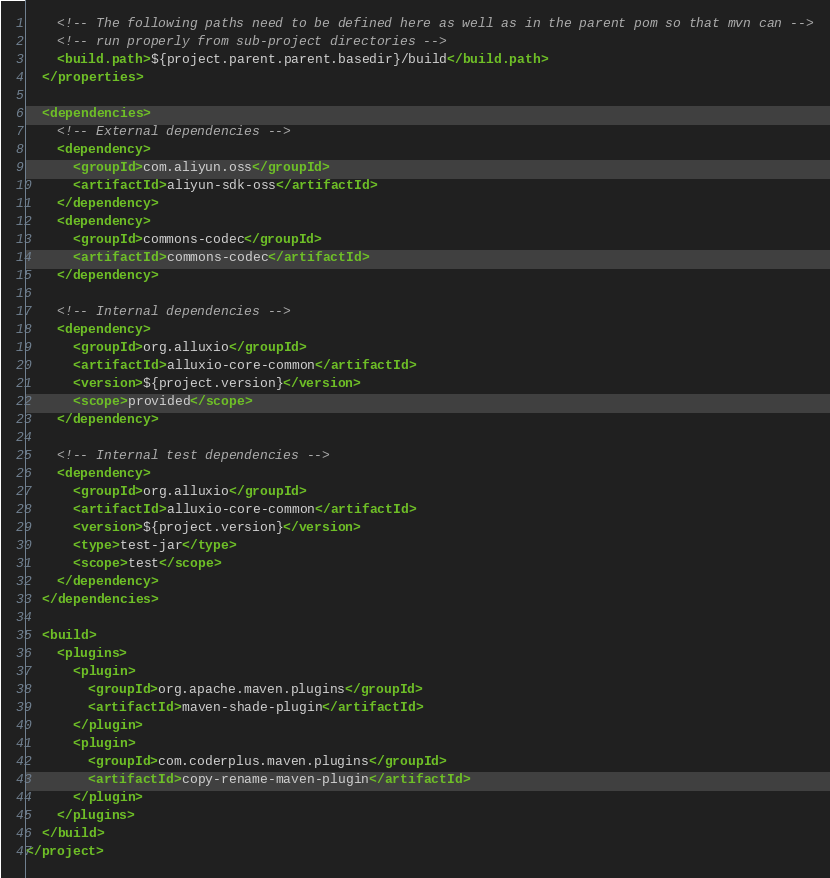<code> <loc_0><loc_0><loc_500><loc_500><_XML_>    <!-- The following paths need to be defined here as well as in the parent pom so that mvn can -->
    <!-- run properly from sub-project directories -->
    <build.path>${project.parent.parent.basedir}/build</build.path>
  </properties>

  <dependencies>
    <!-- External dependencies -->
    <dependency>
      <groupId>com.aliyun.oss</groupId>
      <artifactId>aliyun-sdk-oss</artifactId>
    </dependency>
    <dependency>
      <groupId>commons-codec</groupId>
      <artifactId>commons-codec</artifactId>
    </dependency>

    <!-- Internal dependencies -->
    <dependency>
      <groupId>org.alluxio</groupId>
      <artifactId>alluxio-core-common</artifactId>
      <version>${project.version}</version>
      <scope>provided</scope>
    </dependency>

    <!-- Internal test dependencies -->
    <dependency>
      <groupId>org.alluxio</groupId>
      <artifactId>alluxio-core-common</artifactId>
      <version>${project.version}</version>
      <type>test-jar</type>
      <scope>test</scope>
    </dependency>
  </dependencies>

  <build>
    <plugins>
      <plugin>
        <groupId>org.apache.maven.plugins</groupId>
        <artifactId>maven-shade-plugin</artifactId>
      </plugin>
      <plugin>
        <groupId>com.coderplus.maven.plugins</groupId>
        <artifactId>copy-rename-maven-plugin</artifactId>
      </plugin>
    </plugins>
  </build>
</project>
</code> 